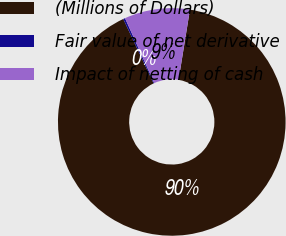Convert chart to OTSL. <chart><loc_0><loc_0><loc_500><loc_500><pie_chart><fcel>(Millions of Dollars)<fcel>Fair value of net derivative<fcel>Impact of netting of cash<nl><fcel>90.44%<fcel>0.27%<fcel>9.29%<nl></chart> 